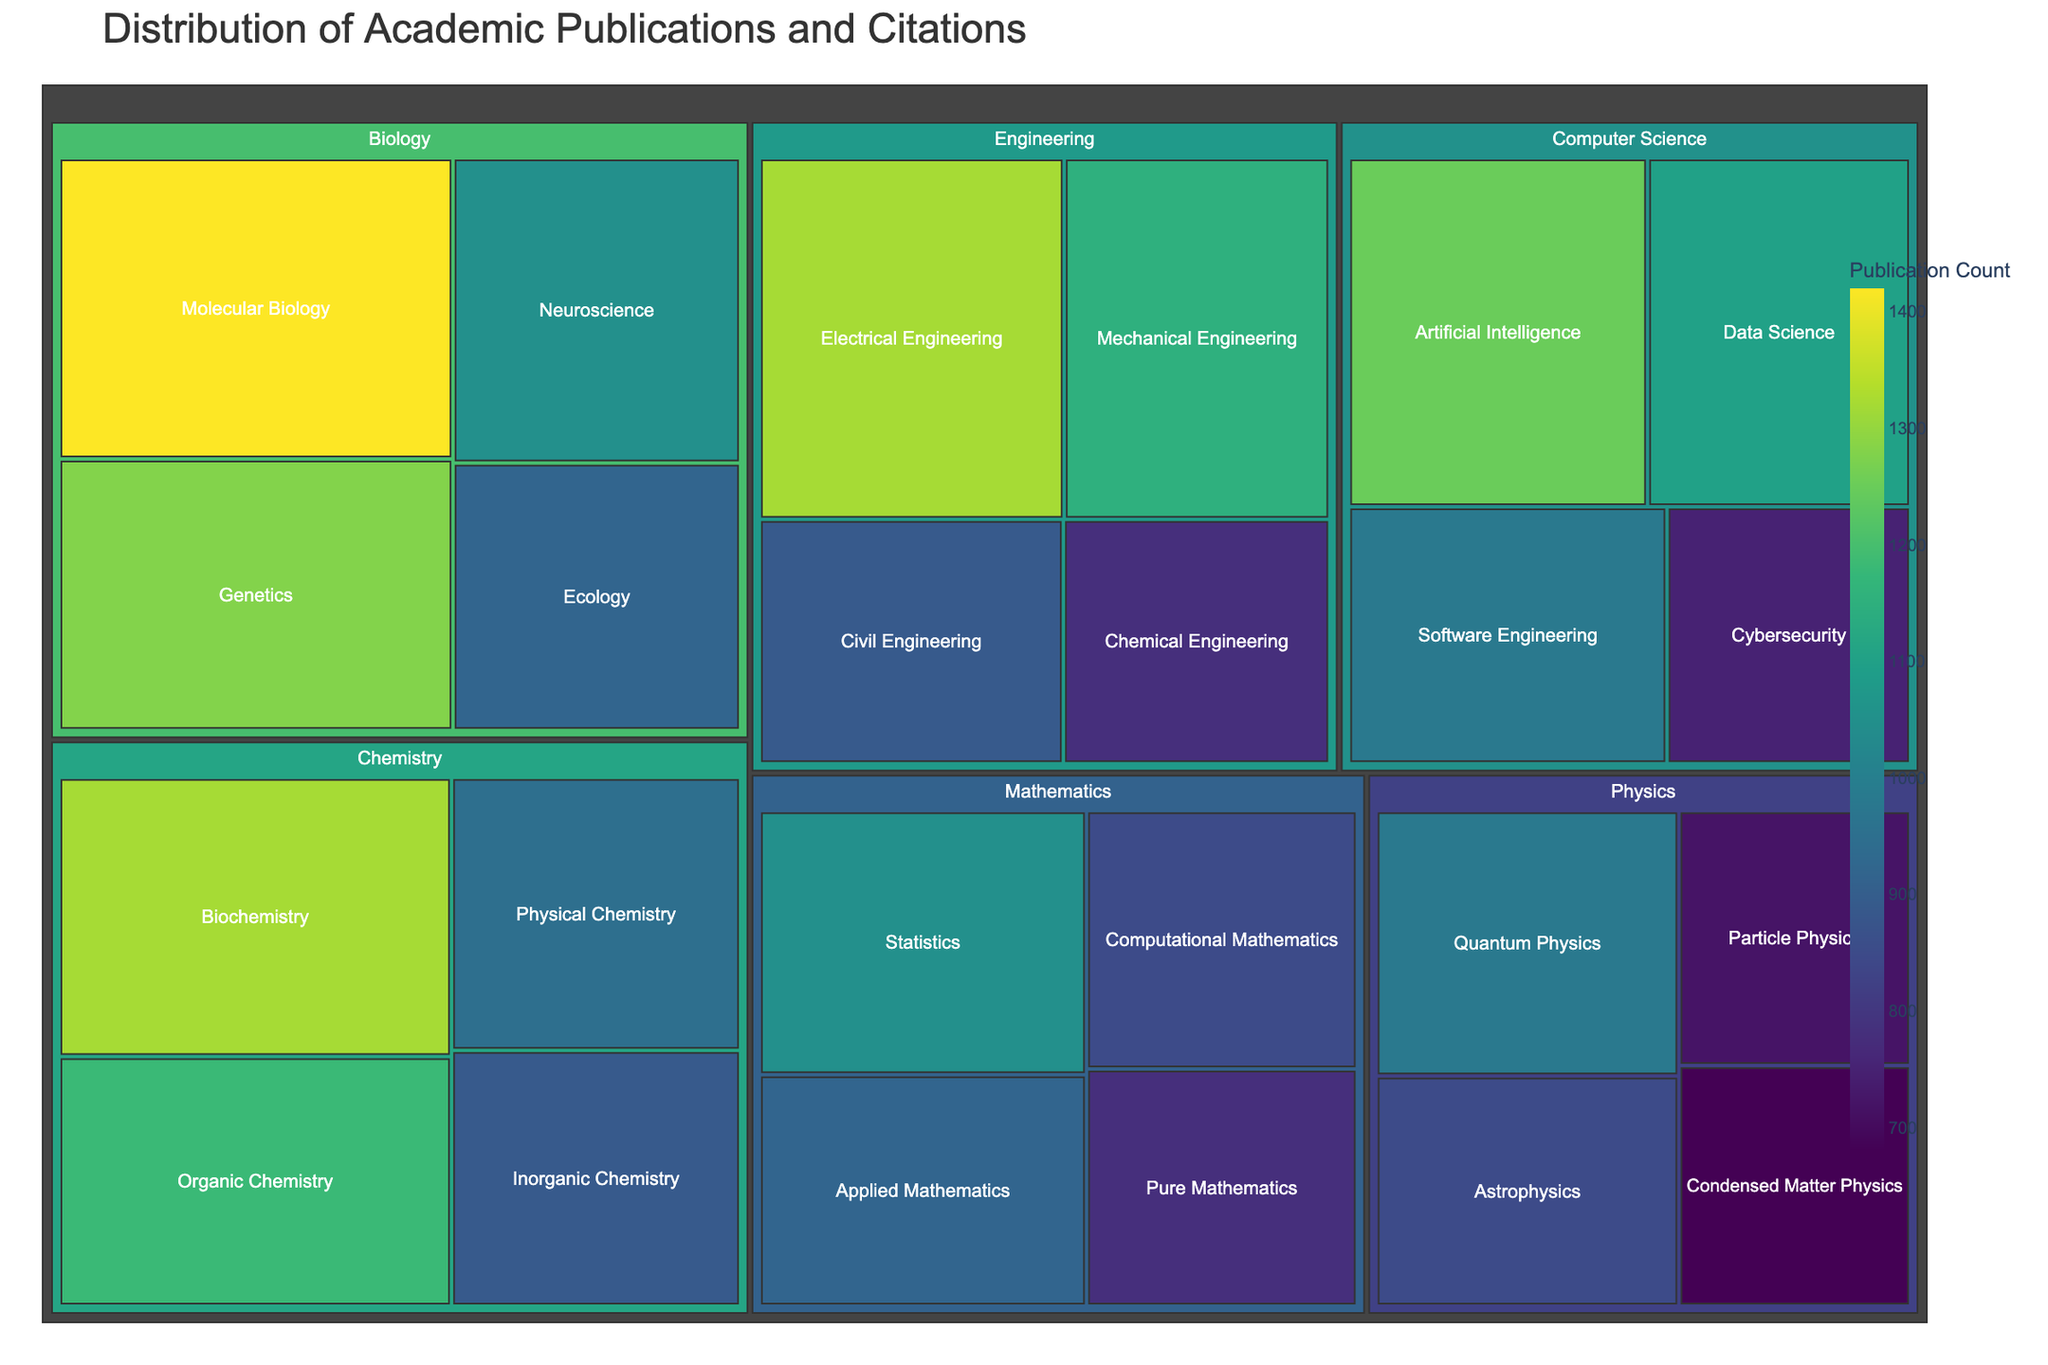What is the title of the figure? The title is shown at the top of the figure, and based on the plot code, it is "Distribution of Academic Publications and Citations".
Answer: Distribution of Academic Publications and Citations Which subcategory within Biology has the highest publication count? By examining the subcategories under Biology, we see the counts: Molecular Biology (1420), Genetics (1280), Ecology (920), Neuroscience (1050). The highest count is Molecular Biology with 1420.
Answer: Molecular Biology What is the combined publication count of all subcategories within Physics? Adding the publication counts for Physics subcategories: Quantum Physics (980) + Astrophysics (850) + Particle Physics (720) + Condensed Matter Physics (680) = 3230.
Answer: 3230 Which category has the most publications? We need to compare the summed values of each category. After adding up the values:
    - Computer Science: 1250 + 980 + 1100 + 750 = 4080
    - Engineering: 1320 + 1150 + 890 + 780 = 4140
    - Physics: 980 + 850 + 720 + 680 = 3230
    - Biology: 1420 + 1280 + 920 + 1050 = 4670
    - Chemistry: 1180 + 890 + 950 + 1320 = 4340
    - Mathematics: 780 + 920 + 1050 + 850 = 3600
  The highest total is for Biology with 4670 publications.
Answer: Biology How does the publication count for Electrical Engineering compare to that for Pure Mathematics? The publication count for Electrical Engineering is 1320, while for Pure Mathematics it is 780. Comparing these, Electrical Engineering has more publications.
Answer: Electrical Engineering has more Which category has the least publications, and what is the publication count? Summing the values for each category, the smallest total comes from Physics with 3230 publications.
Answer: Physics with 3230 In Computer Science, which subcategory has the second highest publication count? Checking the counts for Computer Science: Artificial Intelligence (1250), Software Engineering (980), Data Science (1100), Cybersecurity (750). The second highest count is Data Science with 1100.
Answer: Data Science What is the average publication count per subcategory in Chemistry? There are 4 subcategories in Chemistry. Summing their values: Organic Chemistry (1180) + Inorganic Chemistry (890) + Physical Chemistry (950) + Biochemistry (1320) = 4340. Dividing by 4, the average count is 4340 / 4 = 1085.
Answer: 1085 Which subcategory in the figure has the lowest publication count? Checking across all subcategories, the lowest value is for Condensed Matter Physics at 680.
Answer: Condensed Matter Physics 